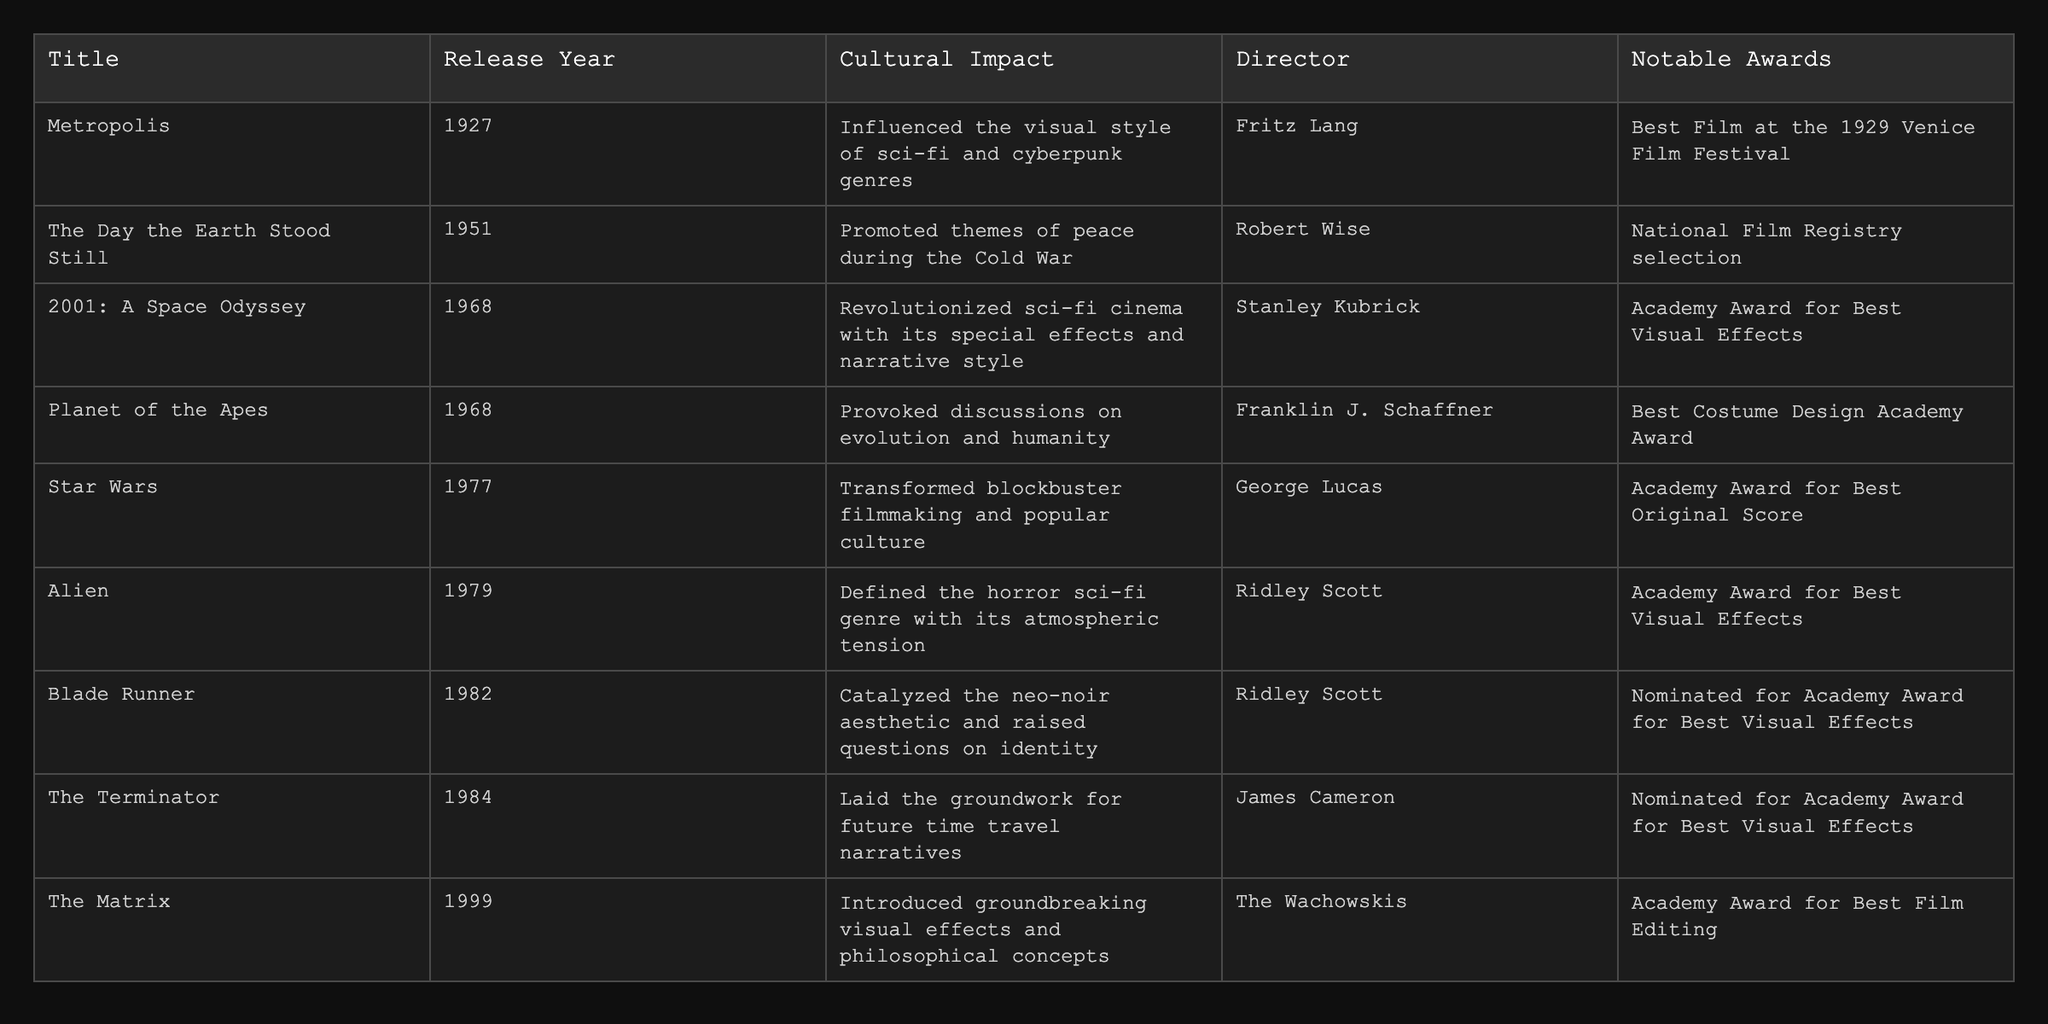What year was "Metropolis" released? The table shows that "Metropolis" was released in the year 1927 under the Release Year column.
Answer: 1927 Which film promoted themes of peace during the Cold War? According to the Cultural Impact column, "The Day the Earth Stood Still" is noted for promoting themes of peace during the Cold War.
Answer: The Day the Earth Stood Still How many films mentioned received an Academy Award for Best Visual Effects? The table lists "2001: A Space Odyssey," "Alien," and "Blade Runner" as films that received or were nominated for Best Visual Effects, totaling three films.
Answer: 3 Which film has the latest release date among those listed? Scanning the Release Year column, "The Matrix" released in 1999 is the latest compared to all other films.
Answer: The Matrix True or False: "Blade Runner" received an Academy Award for Best Picture. The table indicates that "Blade Runner" was nominated for an Academy Award but does not state it won Best Picture; therefore, the statement is false.
Answer: False Compare the cultural impacts of "Planet of the Apes" and "Alien": which one raises questions on humanity? Checking the Cultural Impact column, "Planet of the Apes" provokes discussions on evolution and humanity, while "Alien" defines the horror sci-fi genre; thus, "Planet of the Apes" raises questions on humanity.
Answer: Planet of the Apes What notable award did "Star Wars" win? The table shows that "Star Wars" won the Academy Award for Best Original Score.
Answer: Best Original Score Which director helmed the earliest film in the table? Referring to the Release Year, "Metropolis" is the earliest film directed by Fritz Lang.
Answer: Fritz Lang How many films directed by Ridley Scott are mentioned in the table? The table includes two films directed by Ridley Scott: "Alien" and "Blade Runner," so there are two films.
Answer: 2 What is the cultural impact of "2001: A Space Odyssey"? The table states that "2001: A Space Odyssey" revolutionized sci-fi cinema with its special effects and narrative style.
Answer: Revolutionized sci-fi cinema with special effects Which film is noted for catalyzing the neo-noir aesthetic? According to the Cultural Impact column, "Blade Runner" is noted for catalyzing the neo-noir aesthetic.
Answer: Blade Runner 